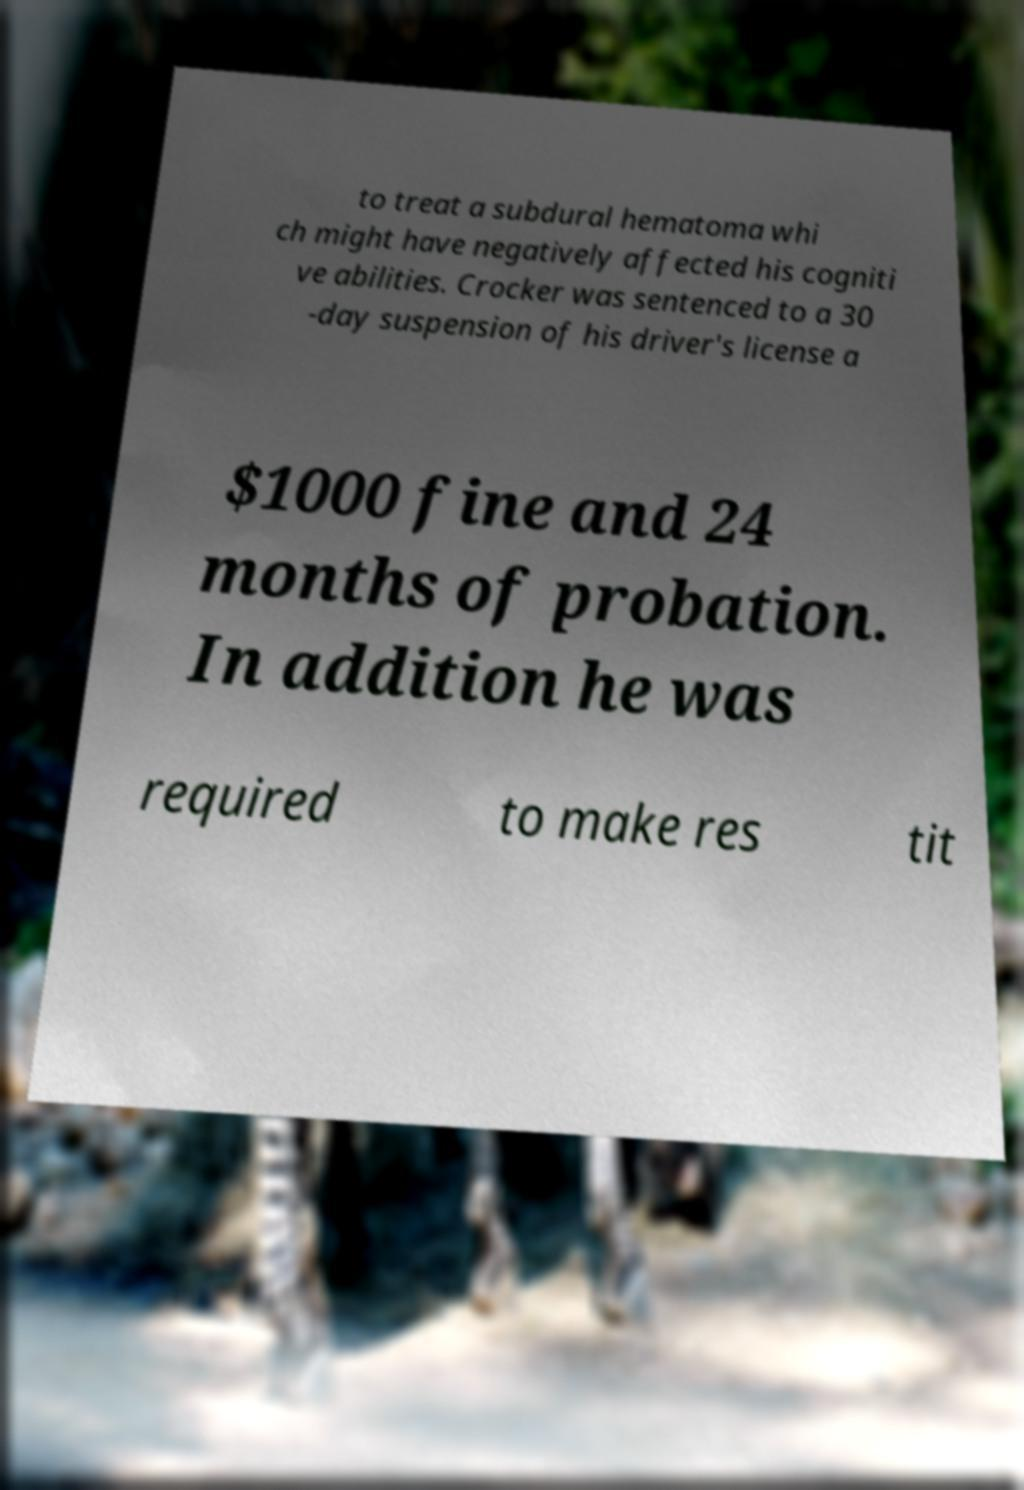Please read and relay the text visible in this image. What does it say? to treat a subdural hematoma whi ch might have negatively affected his cogniti ve abilities. Crocker was sentenced to a 30 -day suspension of his driver's license a $1000 fine and 24 months of probation. In addition he was required to make res tit 